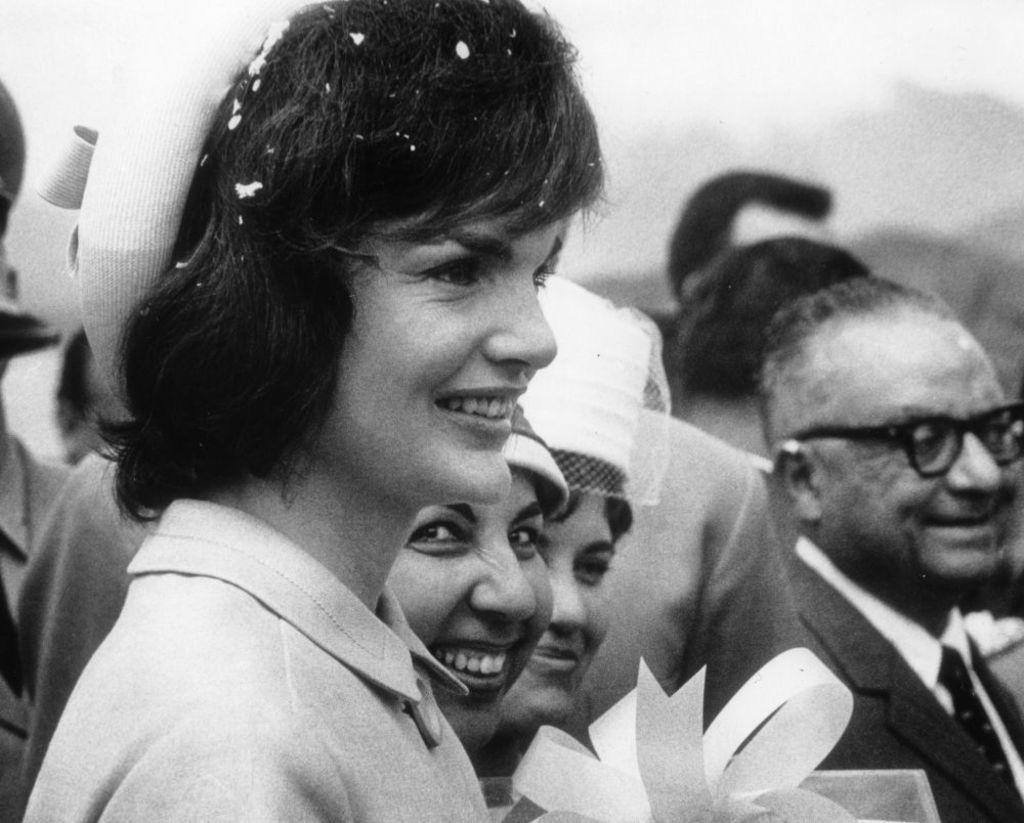What is the color scheme of the image? The image is black and white. What can be seen in the image? There are people in the image. What is the facial expression of the people in the image? The people are smiling. Can you describe the background of the image? The background of the image is blurred. What type of insect can be seen crawling on the people in the image? There are no insects present in the image; it only features people with blurred backgrounds. How does the root system of the trees in the image contribute to the overall composition? There are no trees or roots present in the image; it is a black and white image of people with smiling faces and a blurred background. 